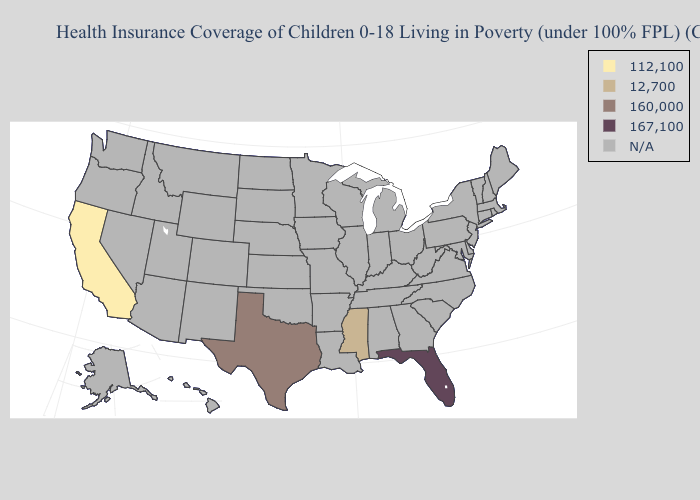Does California have the lowest value in the USA?
Write a very short answer. Yes. Does Texas have the lowest value in the South?
Concise answer only. No. What is the highest value in the South ?
Concise answer only. 167,100. Does California have the lowest value in the USA?
Short answer required. Yes. What is the value of Missouri?
Answer briefly. N/A. Name the states that have a value in the range 112,100?
Give a very brief answer. California. Does California have the lowest value in the USA?
Answer briefly. Yes. Name the states that have a value in the range 167,100?
Be succinct. Florida. Does the first symbol in the legend represent the smallest category?
Be succinct. Yes. Among the states that border New Mexico , which have the lowest value?
Concise answer only. Texas. 